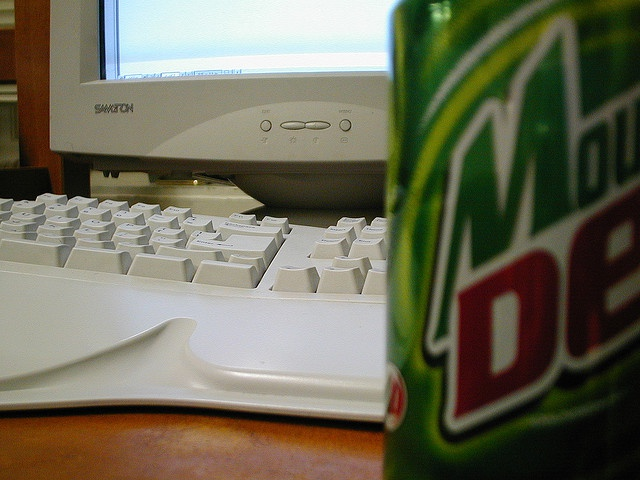Describe the objects in this image and their specific colors. I can see keyboard in olive, darkgray, lightgray, and gray tones and tv in olive, white, gray, black, and darkgray tones in this image. 